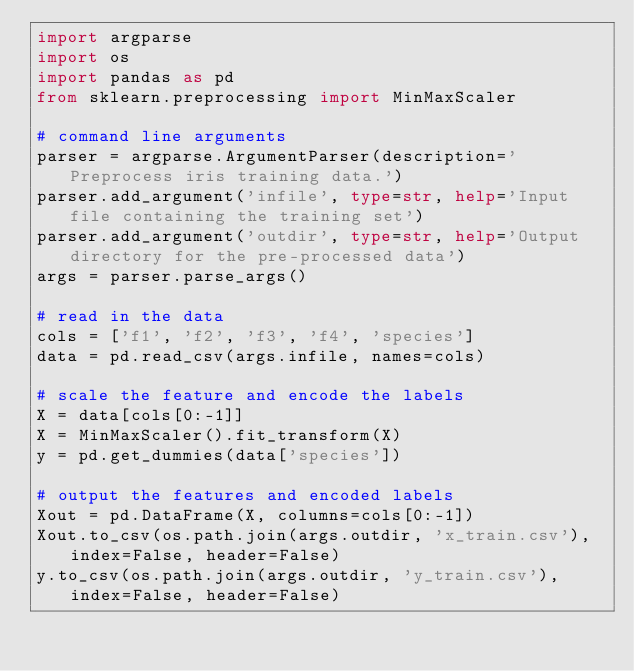<code> <loc_0><loc_0><loc_500><loc_500><_Python_>import argparse
import os
import pandas as pd
from sklearn.preprocessing import MinMaxScaler

# command line arguments
parser = argparse.ArgumentParser(description='Preprocess iris training data.')
parser.add_argument('infile', type=str, help='Input file containing the training set')
parser.add_argument('outdir', type=str, help='Output directory for the pre-processed data')
args = parser.parse_args()

# read in the data
cols = ['f1', 'f2', 'f3', 'f4', 'species']
data = pd.read_csv(args.infile, names=cols)

# scale the feature and encode the labels
X = data[cols[0:-1]]
X = MinMaxScaler().fit_transform(X)
y = pd.get_dummies(data['species'])

# output the features and encoded labels
Xout = pd.DataFrame(X, columns=cols[0:-1])
Xout.to_csv(os.path.join(args.outdir, 'x_train.csv'), index=False, header=False)
y.to_csv(os.path.join(args.outdir, 'y_train.csv'), index=False, header=False)
</code> 